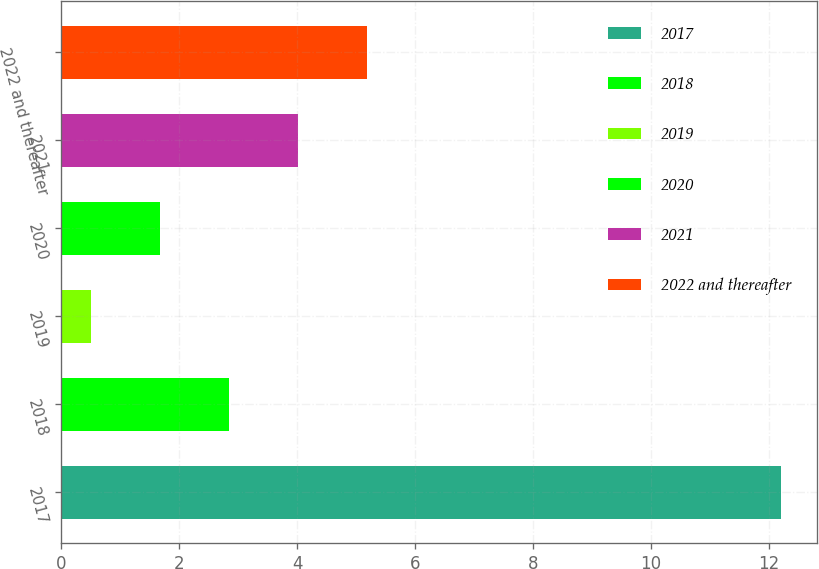Convert chart to OTSL. <chart><loc_0><loc_0><loc_500><loc_500><bar_chart><fcel>2017<fcel>2018<fcel>2019<fcel>2020<fcel>2021<fcel>2022 and thereafter<nl><fcel>12.2<fcel>2.84<fcel>0.5<fcel>1.67<fcel>4.01<fcel>5.18<nl></chart> 